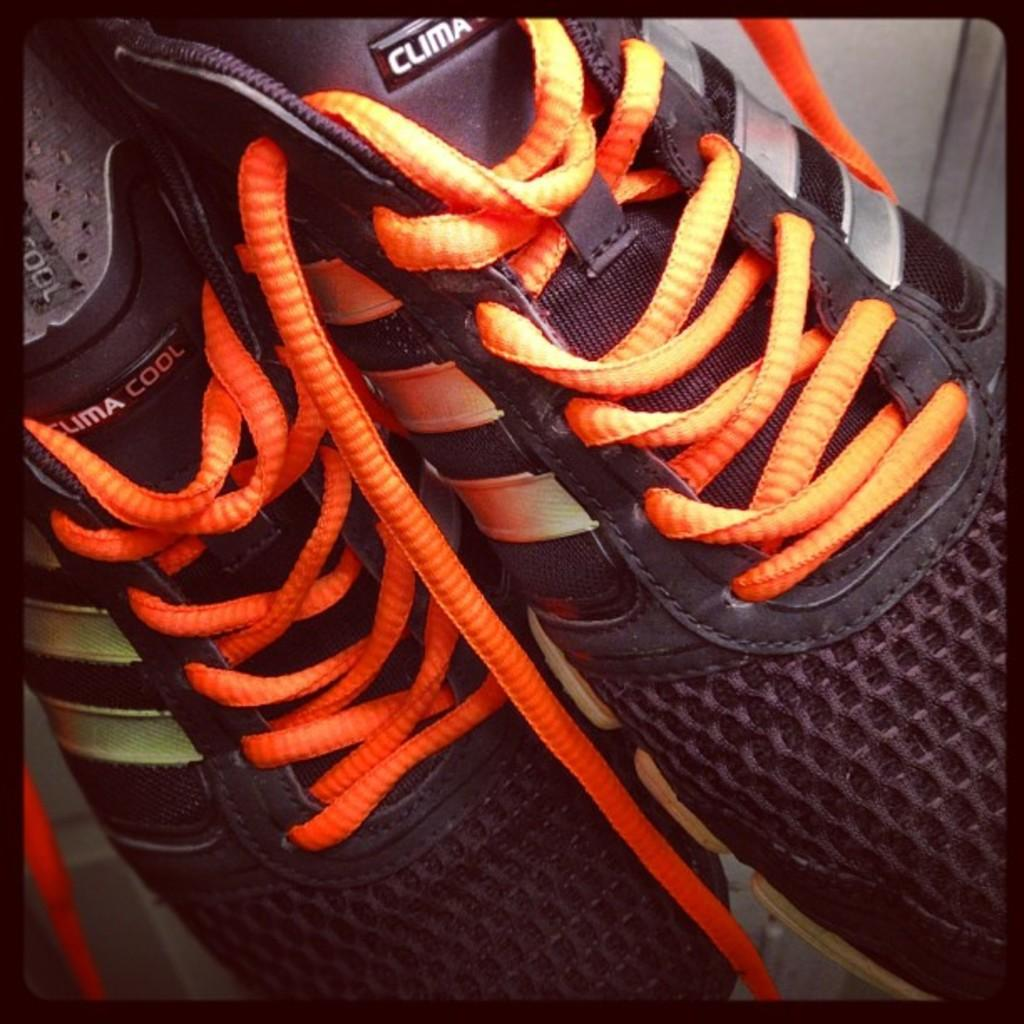What objects can be seen in the image? There are shoes in the image. Where is the door located in the image? The door is in the right top of the image. How many bottles are visible in the image? There are no bottles present in the image. What type of animal can be seen feeling shame in the image? There are no animals or feelings of shame depicted in the image. 